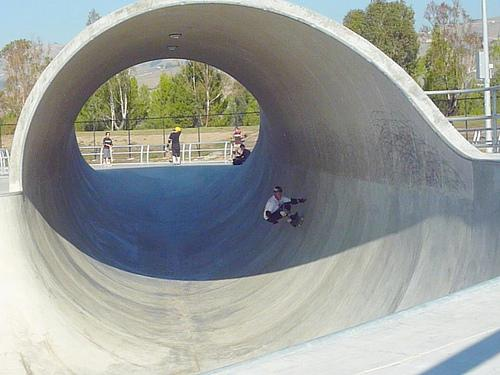Question: what is the man riding?
Choices:
A. A bike.
B. A skateboard.
C. A horse.
D. A motorcycle.
Answer with the letter. Answer: B Question: what color is the skate ramp?
Choices:
A. Black.
B. White.
C. Brown.
D. Gray.
Answer with the letter. Answer: D 